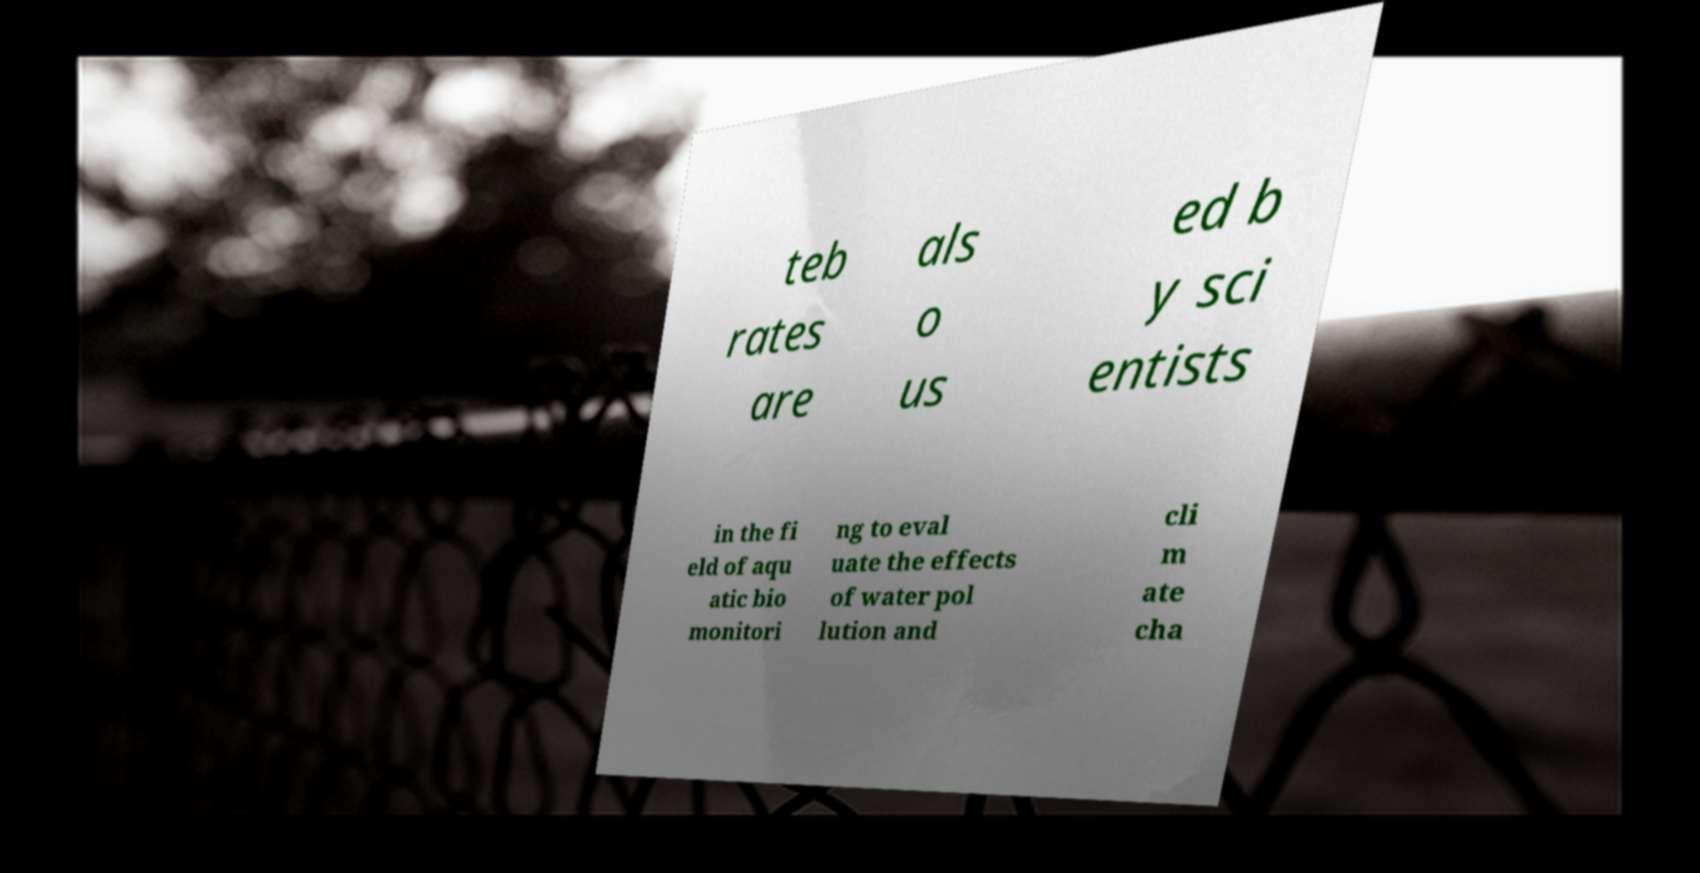Could you extract and type out the text from this image? teb rates are als o us ed b y sci entists in the fi eld of aqu atic bio monitori ng to eval uate the effects of water pol lution and cli m ate cha 